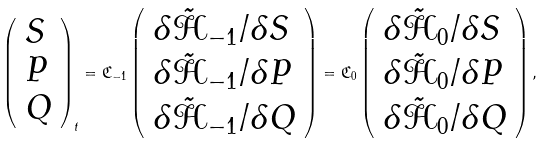Convert formula to latex. <formula><loc_0><loc_0><loc_500><loc_500>\left ( \begin{array} { l } S \\ P \\ Q \\ \end{array} \right ) _ { t } = \mathfrak C _ { - 1 } \left ( \begin{array} { l } \delta \tilde { \mathcal { H } } _ { - 1 } / \delta S \\ \delta \tilde { \mathcal { H } } _ { - 1 } / \delta P \\ \delta \tilde { \mathcal { H } } _ { - 1 } / \delta Q \\ \end{array} \right ) = \mathfrak C _ { 0 } \left ( \begin{array} { l } \delta \tilde { \mathcal { H } } _ { 0 } / \delta S \\ \delta \tilde { \mathcal { H } } _ { 0 } / \delta P \\ \delta \tilde { \mathcal { H } } _ { 0 } / \delta Q \\ \end{array} \right ) ,</formula> 